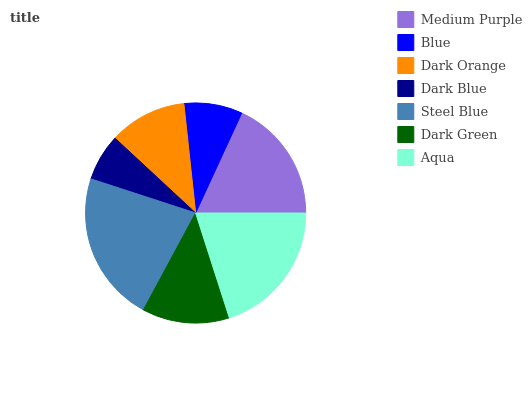Is Dark Blue the minimum?
Answer yes or no. Yes. Is Steel Blue the maximum?
Answer yes or no. Yes. Is Blue the minimum?
Answer yes or no. No. Is Blue the maximum?
Answer yes or no. No. Is Medium Purple greater than Blue?
Answer yes or no. Yes. Is Blue less than Medium Purple?
Answer yes or no. Yes. Is Blue greater than Medium Purple?
Answer yes or no. No. Is Medium Purple less than Blue?
Answer yes or no. No. Is Dark Green the high median?
Answer yes or no. Yes. Is Dark Green the low median?
Answer yes or no. Yes. Is Medium Purple the high median?
Answer yes or no. No. Is Medium Purple the low median?
Answer yes or no. No. 